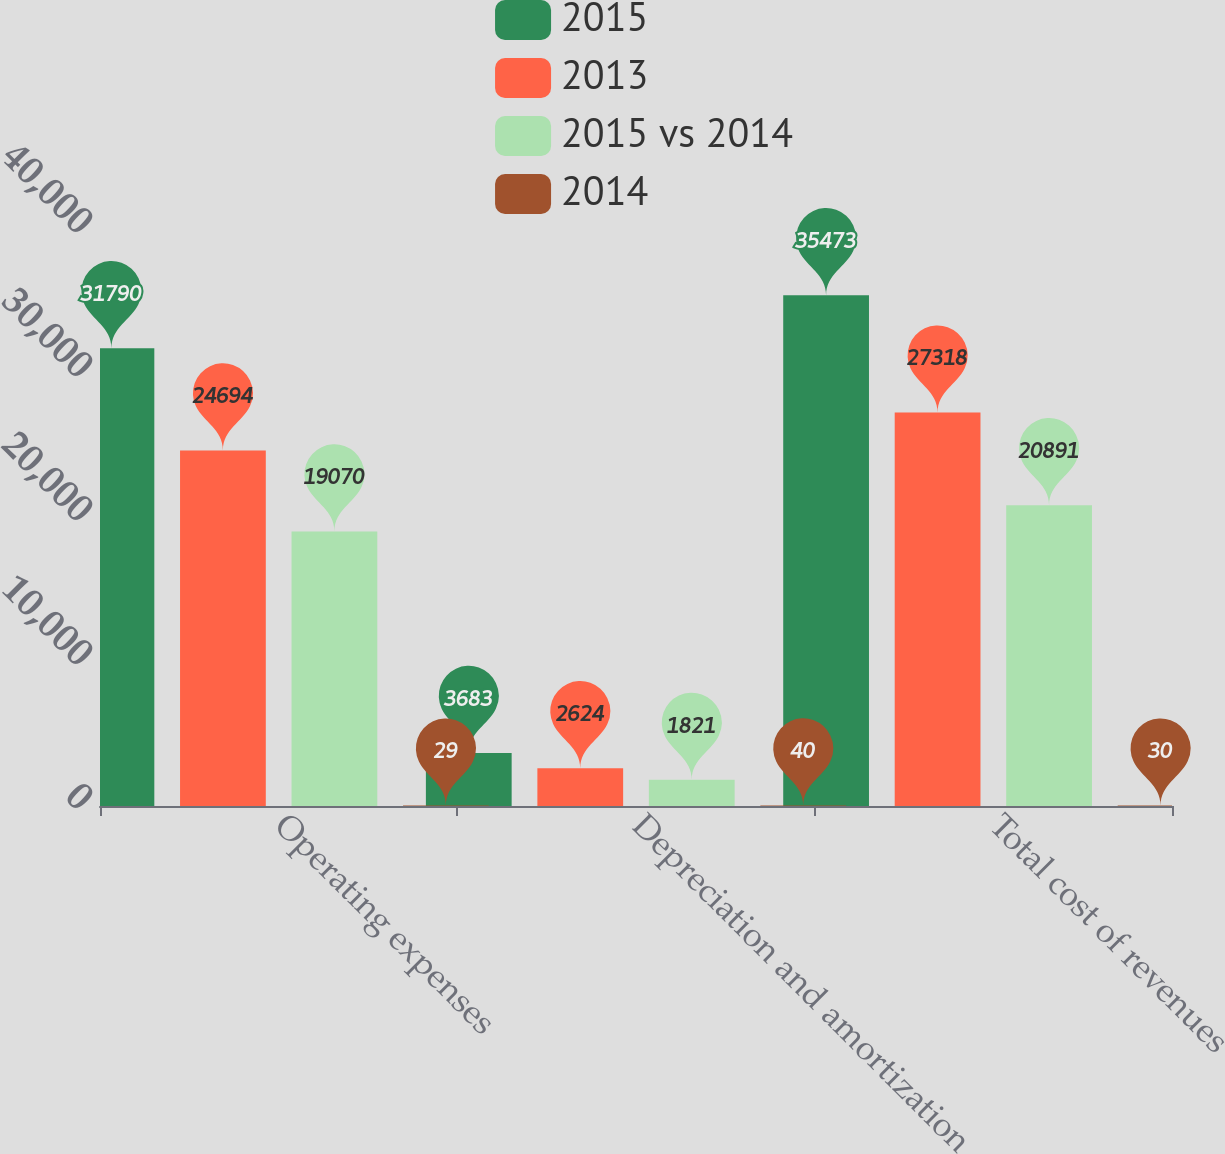Convert chart to OTSL. <chart><loc_0><loc_0><loc_500><loc_500><stacked_bar_chart><ecel><fcel>Operating expenses<fcel>Depreciation and amortization<fcel>Total cost of revenues<nl><fcel>2015<fcel>31790<fcel>3683<fcel>35473<nl><fcel>2013<fcel>24694<fcel>2624<fcel>27318<nl><fcel>2015 vs 2014<fcel>19070<fcel>1821<fcel>20891<nl><fcel>2014<fcel>29<fcel>40<fcel>30<nl></chart> 